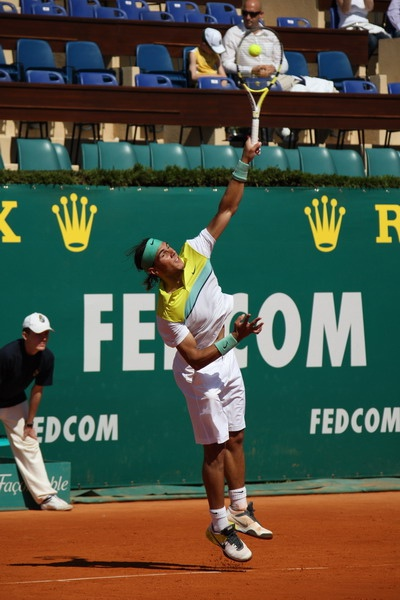Describe the objects in this image and their specific colors. I can see people in tan, lightgray, black, maroon, and gray tones, chair in tan, black, navy, blue, and gray tones, people in tan, black, lightgray, maroon, and gray tones, people in tan, lightgray, darkgray, gray, and black tones, and tennis racket in tan, lightgray, darkgray, gray, and black tones in this image. 